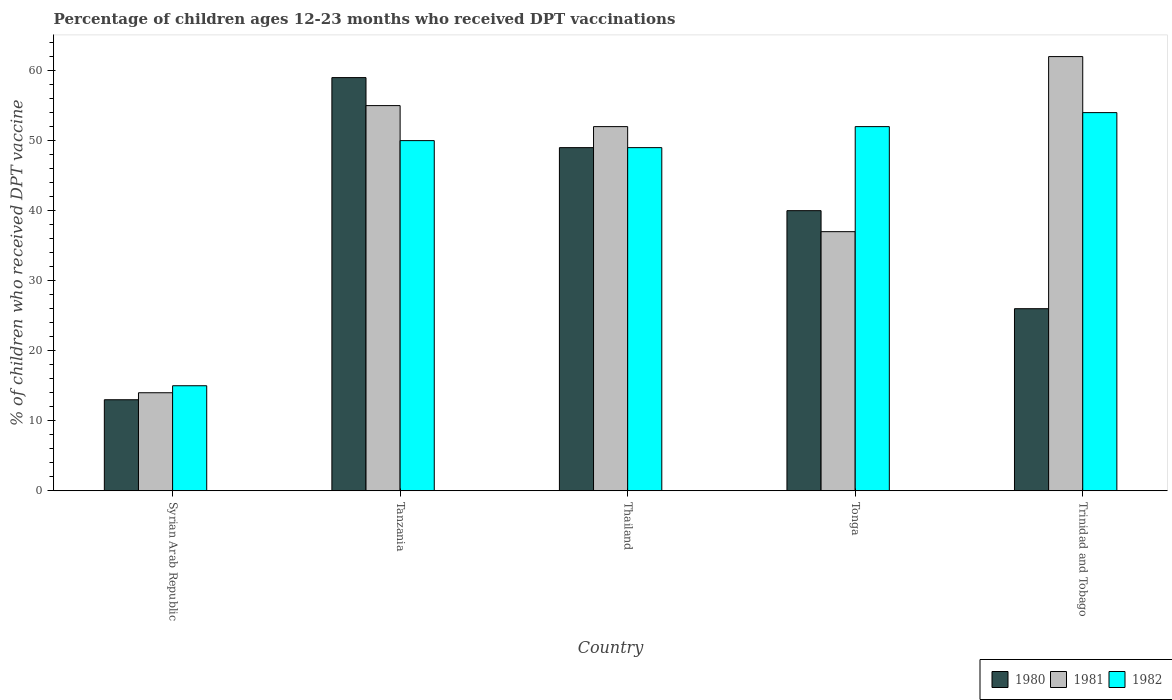How many different coloured bars are there?
Ensure brevity in your answer.  3. Are the number of bars per tick equal to the number of legend labels?
Give a very brief answer. Yes. How many bars are there on the 5th tick from the left?
Ensure brevity in your answer.  3. How many bars are there on the 3rd tick from the right?
Make the answer very short. 3. What is the label of the 3rd group of bars from the left?
Your answer should be compact. Thailand. What is the percentage of children who received DPT vaccination in 1980 in Syrian Arab Republic?
Make the answer very short. 13. In which country was the percentage of children who received DPT vaccination in 1980 maximum?
Your response must be concise. Tanzania. In which country was the percentage of children who received DPT vaccination in 1982 minimum?
Ensure brevity in your answer.  Syrian Arab Republic. What is the total percentage of children who received DPT vaccination in 1981 in the graph?
Give a very brief answer. 220. What is the difference between the percentage of children who received DPT vaccination in 1981 in Tonga and the percentage of children who received DPT vaccination in 1980 in Syrian Arab Republic?
Your answer should be very brief. 24. What is the average percentage of children who received DPT vaccination in 1980 per country?
Ensure brevity in your answer.  37.4. In how many countries, is the percentage of children who received DPT vaccination in 1980 greater than 40 %?
Offer a terse response. 2. What is the ratio of the percentage of children who received DPT vaccination in 1980 in Tanzania to that in Thailand?
Give a very brief answer. 1.2. Is the percentage of children who received DPT vaccination in 1980 in Tanzania less than that in Tonga?
Offer a terse response. No. What is the difference between the highest and the second highest percentage of children who received DPT vaccination in 1982?
Ensure brevity in your answer.  -2. Is the sum of the percentage of children who received DPT vaccination in 1982 in Tonga and Trinidad and Tobago greater than the maximum percentage of children who received DPT vaccination in 1981 across all countries?
Provide a succinct answer. Yes. What does the 3rd bar from the left in Trinidad and Tobago represents?
Ensure brevity in your answer.  1982. What does the 2nd bar from the right in Thailand represents?
Keep it short and to the point. 1981. Is it the case that in every country, the sum of the percentage of children who received DPT vaccination in 1980 and percentage of children who received DPT vaccination in 1981 is greater than the percentage of children who received DPT vaccination in 1982?
Offer a very short reply. Yes. How many countries are there in the graph?
Provide a short and direct response. 5. What is the difference between two consecutive major ticks on the Y-axis?
Your response must be concise. 10. Are the values on the major ticks of Y-axis written in scientific E-notation?
Your response must be concise. No. Does the graph contain grids?
Provide a succinct answer. No. How many legend labels are there?
Make the answer very short. 3. What is the title of the graph?
Your answer should be very brief. Percentage of children ages 12-23 months who received DPT vaccinations. What is the label or title of the Y-axis?
Ensure brevity in your answer.  % of children who received DPT vaccine. What is the % of children who received DPT vaccine of 1980 in Syrian Arab Republic?
Provide a short and direct response. 13. What is the % of children who received DPT vaccine of 1981 in Tanzania?
Your answer should be very brief. 55. What is the % of children who received DPT vaccine in 1980 in Thailand?
Offer a terse response. 49. What is the % of children who received DPT vaccine in 1980 in Tonga?
Give a very brief answer. 40. What is the % of children who received DPT vaccine of 1981 in Tonga?
Ensure brevity in your answer.  37. What is the % of children who received DPT vaccine in 1982 in Tonga?
Provide a succinct answer. 52. Across all countries, what is the maximum % of children who received DPT vaccine in 1981?
Ensure brevity in your answer.  62. Across all countries, what is the maximum % of children who received DPT vaccine of 1982?
Provide a succinct answer. 54. Across all countries, what is the minimum % of children who received DPT vaccine of 1980?
Give a very brief answer. 13. What is the total % of children who received DPT vaccine in 1980 in the graph?
Give a very brief answer. 187. What is the total % of children who received DPT vaccine of 1981 in the graph?
Make the answer very short. 220. What is the total % of children who received DPT vaccine in 1982 in the graph?
Your response must be concise. 220. What is the difference between the % of children who received DPT vaccine of 1980 in Syrian Arab Republic and that in Tanzania?
Offer a terse response. -46. What is the difference between the % of children who received DPT vaccine of 1981 in Syrian Arab Republic and that in Tanzania?
Provide a succinct answer. -41. What is the difference between the % of children who received DPT vaccine in 1982 in Syrian Arab Republic and that in Tanzania?
Make the answer very short. -35. What is the difference between the % of children who received DPT vaccine in 1980 in Syrian Arab Republic and that in Thailand?
Offer a very short reply. -36. What is the difference between the % of children who received DPT vaccine in 1981 in Syrian Arab Republic and that in Thailand?
Make the answer very short. -38. What is the difference between the % of children who received DPT vaccine of 1982 in Syrian Arab Republic and that in Thailand?
Give a very brief answer. -34. What is the difference between the % of children who received DPT vaccine of 1980 in Syrian Arab Republic and that in Tonga?
Your response must be concise. -27. What is the difference between the % of children who received DPT vaccine in 1981 in Syrian Arab Republic and that in Tonga?
Provide a succinct answer. -23. What is the difference between the % of children who received DPT vaccine in 1982 in Syrian Arab Republic and that in Tonga?
Your response must be concise. -37. What is the difference between the % of children who received DPT vaccine in 1980 in Syrian Arab Republic and that in Trinidad and Tobago?
Offer a terse response. -13. What is the difference between the % of children who received DPT vaccine in 1981 in Syrian Arab Republic and that in Trinidad and Tobago?
Your answer should be very brief. -48. What is the difference between the % of children who received DPT vaccine of 1982 in Syrian Arab Republic and that in Trinidad and Tobago?
Your response must be concise. -39. What is the difference between the % of children who received DPT vaccine of 1982 in Tanzania and that in Thailand?
Ensure brevity in your answer.  1. What is the difference between the % of children who received DPT vaccine of 1980 in Tanzania and that in Tonga?
Offer a very short reply. 19. What is the difference between the % of children who received DPT vaccine in 1982 in Tanzania and that in Tonga?
Keep it short and to the point. -2. What is the difference between the % of children who received DPT vaccine of 1980 in Tanzania and that in Trinidad and Tobago?
Provide a short and direct response. 33. What is the difference between the % of children who received DPT vaccine of 1981 in Tanzania and that in Trinidad and Tobago?
Ensure brevity in your answer.  -7. What is the difference between the % of children who received DPT vaccine in 1981 in Thailand and that in Tonga?
Keep it short and to the point. 15. What is the difference between the % of children who received DPT vaccine of 1982 in Thailand and that in Tonga?
Your answer should be compact. -3. What is the difference between the % of children who received DPT vaccine of 1982 in Tonga and that in Trinidad and Tobago?
Make the answer very short. -2. What is the difference between the % of children who received DPT vaccine in 1980 in Syrian Arab Republic and the % of children who received DPT vaccine in 1981 in Tanzania?
Offer a terse response. -42. What is the difference between the % of children who received DPT vaccine in 1980 in Syrian Arab Republic and the % of children who received DPT vaccine in 1982 in Tanzania?
Keep it short and to the point. -37. What is the difference between the % of children who received DPT vaccine of 1981 in Syrian Arab Republic and the % of children who received DPT vaccine of 1982 in Tanzania?
Ensure brevity in your answer.  -36. What is the difference between the % of children who received DPT vaccine in 1980 in Syrian Arab Republic and the % of children who received DPT vaccine in 1981 in Thailand?
Your answer should be compact. -39. What is the difference between the % of children who received DPT vaccine of 1980 in Syrian Arab Republic and the % of children who received DPT vaccine of 1982 in Thailand?
Offer a very short reply. -36. What is the difference between the % of children who received DPT vaccine in 1981 in Syrian Arab Republic and the % of children who received DPT vaccine in 1982 in Thailand?
Your response must be concise. -35. What is the difference between the % of children who received DPT vaccine in 1980 in Syrian Arab Republic and the % of children who received DPT vaccine in 1981 in Tonga?
Ensure brevity in your answer.  -24. What is the difference between the % of children who received DPT vaccine in 1980 in Syrian Arab Republic and the % of children who received DPT vaccine in 1982 in Tonga?
Provide a succinct answer. -39. What is the difference between the % of children who received DPT vaccine of 1981 in Syrian Arab Republic and the % of children who received DPT vaccine of 1982 in Tonga?
Your answer should be very brief. -38. What is the difference between the % of children who received DPT vaccine in 1980 in Syrian Arab Republic and the % of children who received DPT vaccine in 1981 in Trinidad and Tobago?
Your response must be concise. -49. What is the difference between the % of children who received DPT vaccine in 1980 in Syrian Arab Republic and the % of children who received DPT vaccine in 1982 in Trinidad and Tobago?
Make the answer very short. -41. What is the difference between the % of children who received DPT vaccine of 1980 in Tanzania and the % of children who received DPT vaccine of 1981 in Thailand?
Offer a terse response. 7. What is the difference between the % of children who received DPT vaccine in 1981 in Tanzania and the % of children who received DPT vaccine in 1982 in Thailand?
Give a very brief answer. 6. What is the difference between the % of children who received DPT vaccine in 1980 in Tanzania and the % of children who received DPT vaccine in 1981 in Trinidad and Tobago?
Offer a terse response. -3. What is the difference between the % of children who received DPT vaccine of 1980 in Thailand and the % of children who received DPT vaccine of 1981 in Tonga?
Give a very brief answer. 12. What is the difference between the % of children who received DPT vaccine of 1981 in Thailand and the % of children who received DPT vaccine of 1982 in Tonga?
Your answer should be compact. 0. What is the difference between the % of children who received DPT vaccine in 1980 in Thailand and the % of children who received DPT vaccine in 1981 in Trinidad and Tobago?
Keep it short and to the point. -13. What is the difference between the % of children who received DPT vaccine in 1980 in Thailand and the % of children who received DPT vaccine in 1982 in Trinidad and Tobago?
Keep it short and to the point. -5. What is the difference between the % of children who received DPT vaccine in 1981 in Thailand and the % of children who received DPT vaccine in 1982 in Trinidad and Tobago?
Your response must be concise. -2. What is the difference between the % of children who received DPT vaccine of 1980 in Tonga and the % of children who received DPT vaccine of 1981 in Trinidad and Tobago?
Ensure brevity in your answer.  -22. What is the average % of children who received DPT vaccine in 1980 per country?
Offer a terse response. 37.4. What is the difference between the % of children who received DPT vaccine of 1980 and % of children who received DPT vaccine of 1981 in Syrian Arab Republic?
Offer a very short reply. -1. What is the difference between the % of children who received DPT vaccine in 1981 and % of children who received DPT vaccine in 1982 in Syrian Arab Republic?
Your response must be concise. -1. What is the difference between the % of children who received DPT vaccine of 1981 and % of children who received DPT vaccine of 1982 in Tanzania?
Your answer should be very brief. 5. What is the difference between the % of children who received DPT vaccine of 1980 and % of children who received DPT vaccine of 1981 in Thailand?
Offer a very short reply. -3. What is the difference between the % of children who received DPT vaccine of 1980 and % of children who received DPT vaccine of 1982 in Thailand?
Your answer should be very brief. 0. What is the difference between the % of children who received DPT vaccine in 1981 and % of children who received DPT vaccine in 1982 in Thailand?
Give a very brief answer. 3. What is the difference between the % of children who received DPT vaccine in 1980 and % of children who received DPT vaccine in 1981 in Trinidad and Tobago?
Ensure brevity in your answer.  -36. What is the difference between the % of children who received DPT vaccine of 1981 and % of children who received DPT vaccine of 1982 in Trinidad and Tobago?
Give a very brief answer. 8. What is the ratio of the % of children who received DPT vaccine of 1980 in Syrian Arab Republic to that in Tanzania?
Provide a short and direct response. 0.22. What is the ratio of the % of children who received DPT vaccine of 1981 in Syrian Arab Republic to that in Tanzania?
Give a very brief answer. 0.25. What is the ratio of the % of children who received DPT vaccine of 1980 in Syrian Arab Republic to that in Thailand?
Ensure brevity in your answer.  0.27. What is the ratio of the % of children who received DPT vaccine in 1981 in Syrian Arab Republic to that in Thailand?
Your answer should be very brief. 0.27. What is the ratio of the % of children who received DPT vaccine of 1982 in Syrian Arab Republic to that in Thailand?
Make the answer very short. 0.31. What is the ratio of the % of children who received DPT vaccine in 1980 in Syrian Arab Republic to that in Tonga?
Ensure brevity in your answer.  0.33. What is the ratio of the % of children who received DPT vaccine of 1981 in Syrian Arab Republic to that in Tonga?
Provide a short and direct response. 0.38. What is the ratio of the % of children who received DPT vaccine in 1982 in Syrian Arab Republic to that in Tonga?
Offer a terse response. 0.29. What is the ratio of the % of children who received DPT vaccine in 1981 in Syrian Arab Republic to that in Trinidad and Tobago?
Keep it short and to the point. 0.23. What is the ratio of the % of children who received DPT vaccine in 1982 in Syrian Arab Republic to that in Trinidad and Tobago?
Provide a short and direct response. 0.28. What is the ratio of the % of children who received DPT vaccine of 1980 in Tanzania to that in Thailand?
Your response must be concise. 1.2. What is the ratio of the % of children who received DPT vaccine in 1981 in Tanzania to that in Thailand?
Give a very brief answer. 1.06. What is the ratio of the % of children who received DPT vaccine of 1982 in Tanzania to that in Thailand?
Your answer should be compact. 1.02. What is the ratio of the % of children who received DPT vaccine of 1980 in Tanzania to that in Tonga?
Provide a succinct answer. 1.48. What is the ratio of the % of children who received DPT vaccine of 1981 in Tanzania to that in Tonga?
Offer a very short reply. 1.49. What is the ratio of the % of children who received DPT vaccine in 1982 in Tanzania to that in Tonga?
Provide a succinct answer. 0.96. What is the ratio of the % of children who received DPT vaccine in 1980 in Tanzania to that in Trinidad and Tobago?
Your response must be concise. 2.27. What is the ratio of the % of children who received DPT vaccine in 1981 in Tanzania to that in Trinidad and Tobago?
Provide a short and direct response. 0.89. What is the ratio of the % of children who received DPT vaccine in 1982 in Tanzania to that in Trinidad and Tobago?
Keep it short and to the point. 0.93. What is the ratio of the % of children who received DPT vaccine in 1980 in Thailand to that in Tonga?
Offer a very short reply. 1.23. What is the ratio of the % of children who received DPT vaccine in 1981 in Thailand to that in Tonga?
Offer a very short reply. 1.41. What is the ratio of the % of children who received DPT vaccine in 1982 in Thailand to that in Tonga?
Provide a short and direct response. 0.94. What is the ratio of the % of children who received DPT vaccine in 1980 in Thailand to that in Trinidad and Tobago?
Your response must be concise. 1.88. What is the ratio of the % of children who received DPT vaccine of 1981 in Thailand to that in Trinidad and Tobago?
Offer a terse response. 0.84. What is the ratio of the % of children who received DPT vaccine of 1982 in Thailand to that in Trinidad and Tobago?
Ensure brevity in your answer.  0.91. What is the ratio of the % of children who received DPT vaccine in 1980 in Tonga to that in Trinidad and Tobago?
Provide a succinct answer. 1.54. What is the ratio of the % of children who received DPT vaccine in 1981 in Tonga to that in Trinidad and Tobago?
Your response must be concise. 0.6. What is the ratio of the % of children who received DPT vaccine in 1982 in Tonga to that in Trinidad and Tobago?
Provide a short and direct response. 0.96. What is the difference between the highest and the second highest % of children who received DPT vaccine in 1980?
Provide a short and direct response. 10. What is the difference between the highest and the second highest % of children who received DPT vaccine of 1981?
Provide a succinct answer. 7. What is the difference between the highest and the lowest % of children who received DPT vaccine of 1980?
Give a very brief answer. 46. What is the difference between the highest and the lowest % of children who received DPT vaccine in 1981?
Offer a very short reply. 48. 